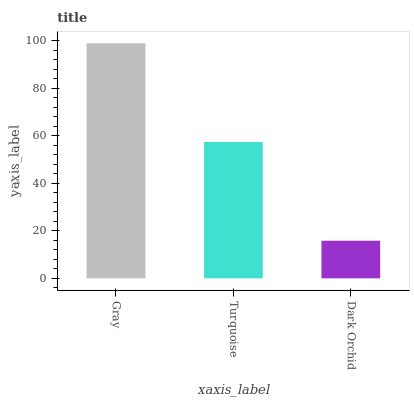Is Dark Orchid the minimum?
Answer yes or no. Yes. Is Gray the maximum?
Answer yes or no. Yes. Is Turquoise the minimum?
Answer yes or no. No. Is Turquoise the maximum?
Answer yes or no. No. Is Gray greater than Turquoise?
Answer yes or no. Yes. Is Turquoise less than Gray?
Answer yes or no. Yes. Is Turquoise greater than Gray?
Answer yes or no. No. Is Gray less than Turquoise?
Answer yes or no. No. Is Turquoise the high median?
Answer yes or no. Yes. Is Turquoise the low median?
Answer yes or no. Yes. Is Gray the high median?
Answer yes or no. No. Is Gray the low median?
Answer yes or no. No. 